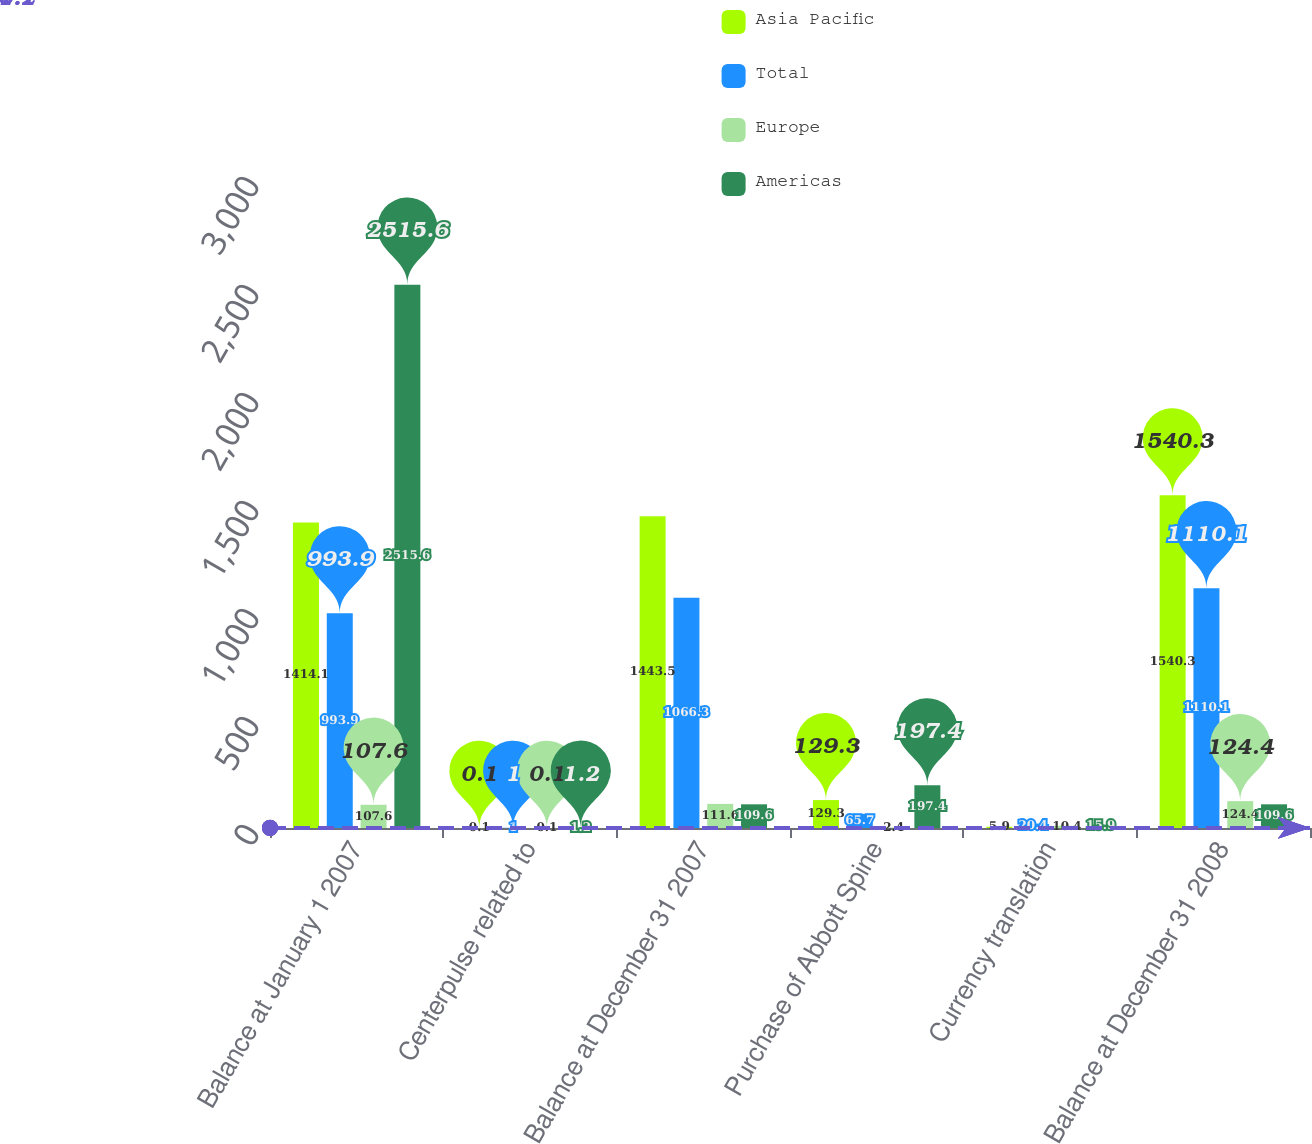Convert chart to OTSL. <chart><loc_0><loc_0><loc_500><loc_500><stacked_bar_chart><ecel><fcel>Balance at January 1 2007<fcel>Centerpulse related to<fcel>Balance at December 31 2007<fcel>Purchase of Abbott Spine<fcel>Currency translation<fcel>Balance at December 31 2008<nl><fcel>Asia Pacific<fcel>1414.1<fcel>0.1<fcel>1443.5<fcel>129.3<fcel>5.9<fcel>1540.3<nl><fcel>Total<fcel>993.9<fcel>1<fcel>1066.3<fcel>65.7<fcel>20.4<fcel>1110.1<nl><fcel>Europe<fcel>107.6<fcel>0.1<fcel>111.6<fcel>2.4<fcel>10.4<fcel>124.4<nl><fcel>Americas<fcel>2515.6<fcel>1.2<fcel>109.6<fcel>197.4<fcel>15.9<fcel>109.6<nl></chart> 